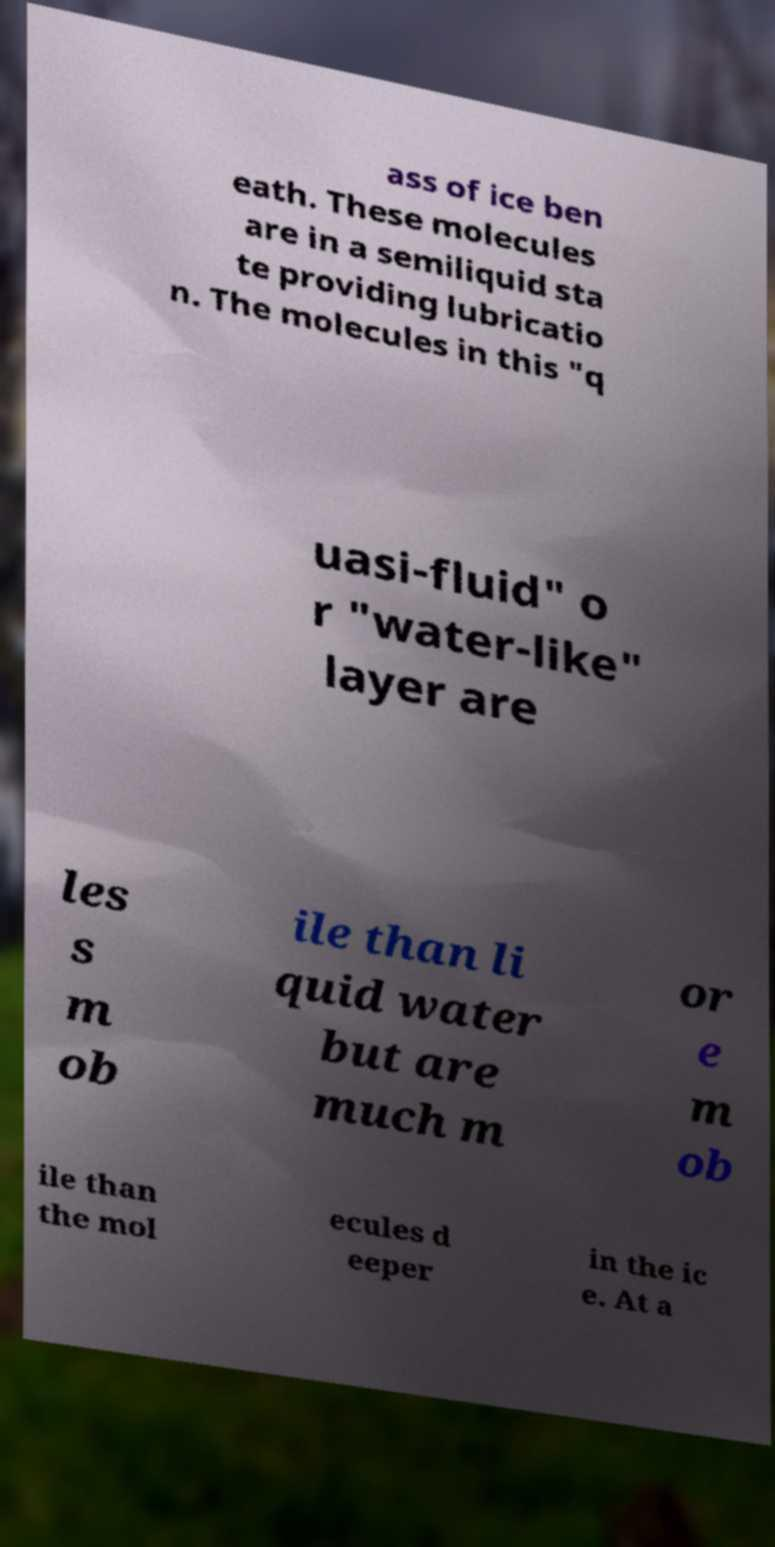Can you read and provide the text displayed in the image?This photo seems to have some interesting text. Can you extract and type it out for me? ass of ice ben eath. These molecules are in a semiliquid sta te providing lubricatio n. The molecules in this "q uasi-fluid" o r "water-like" layer are les s m ob ile than li quid water but are much m or e m ob ile than the mol ecules d eeper in the ic e. At a 